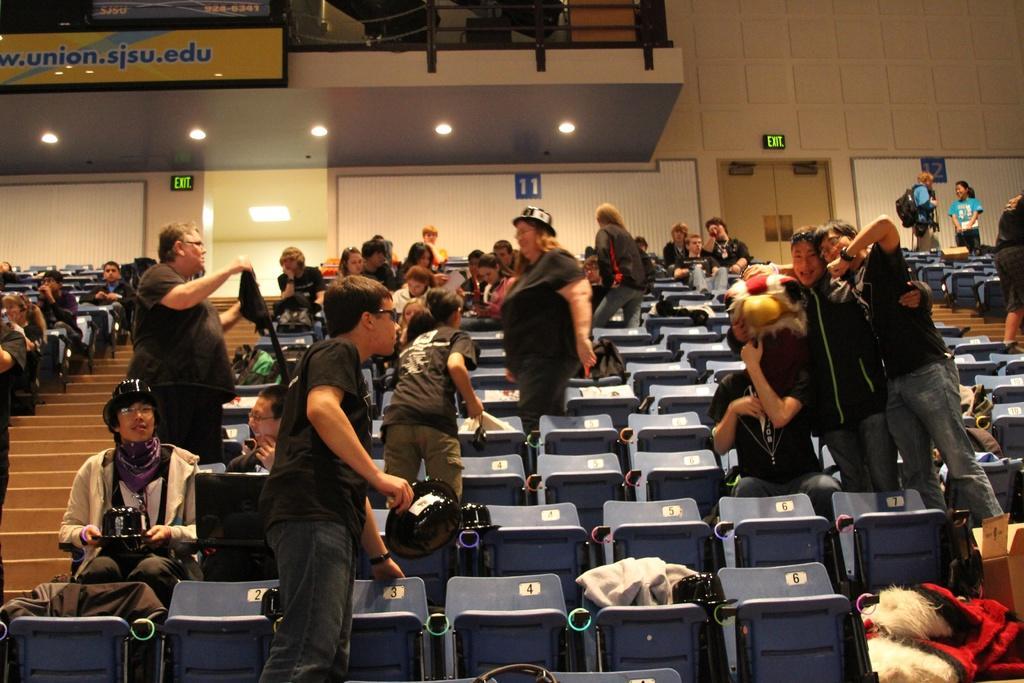How would you summarize this image in a sentence or two? In this image there are people sitting on chairs and few are standing, in the background there is a wall and a roof. 